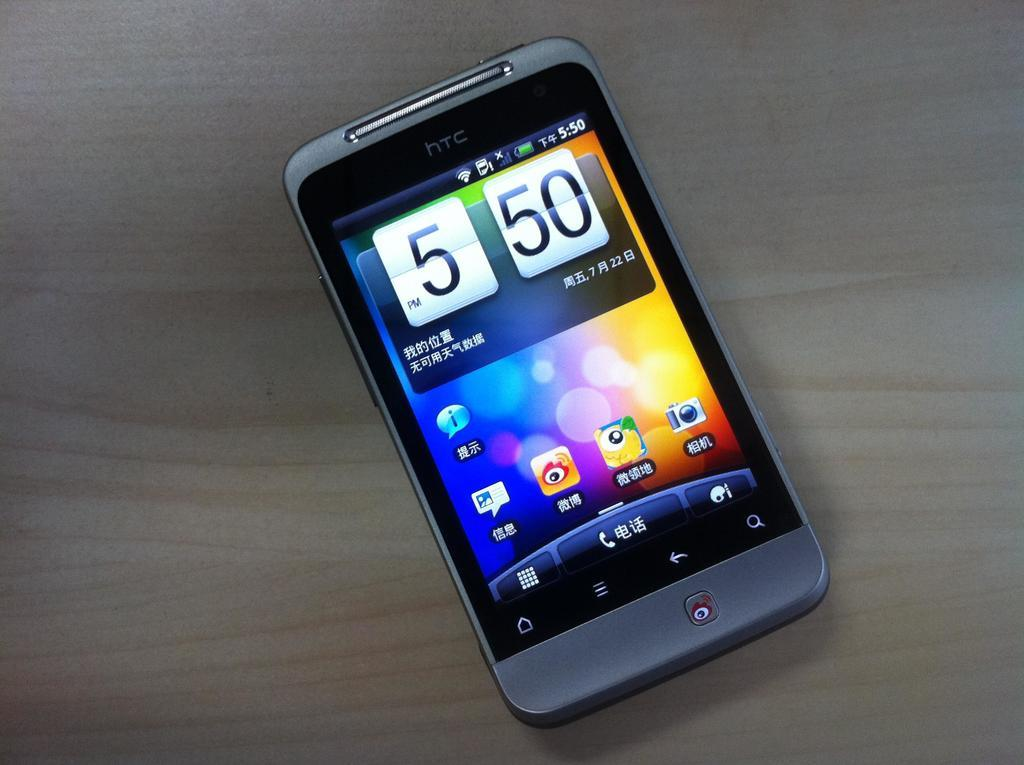What object can be seen in the image? There is a mobile in the image. Where is the mobile located? The mobile is placed on a table. How many goldfish are swimming in the beds in the image? There are no goldfish or beds present in the image; it only features a mobile placed on a table. 